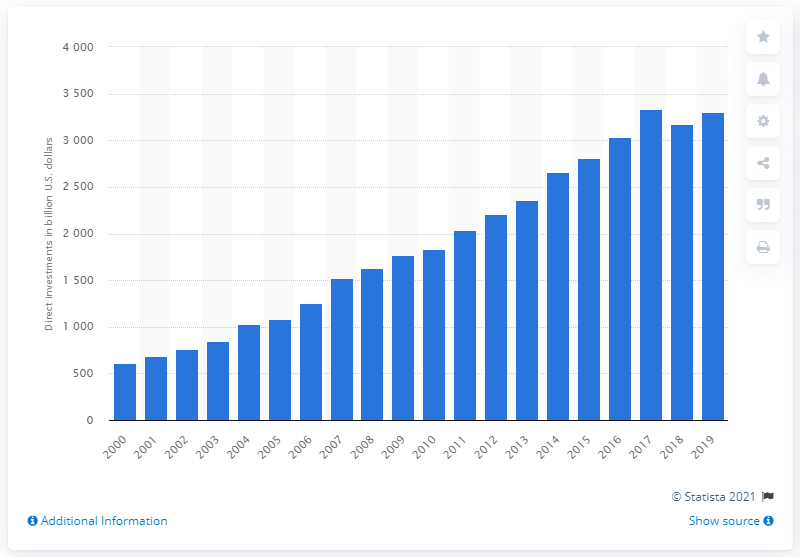Can you describe the trend in investments over the period shown? The image presents a clear upward trend in the United States direct investments in the European Union from 2000 to 2019, with investments increasing significantly, particularly in the years following 2009.  Is there any year where the investment dipped noticeably? Based on the bar chart, there is no year where there is a noticeable dip in the investment amounts; instead, there's a consistent growth throughout this period. 